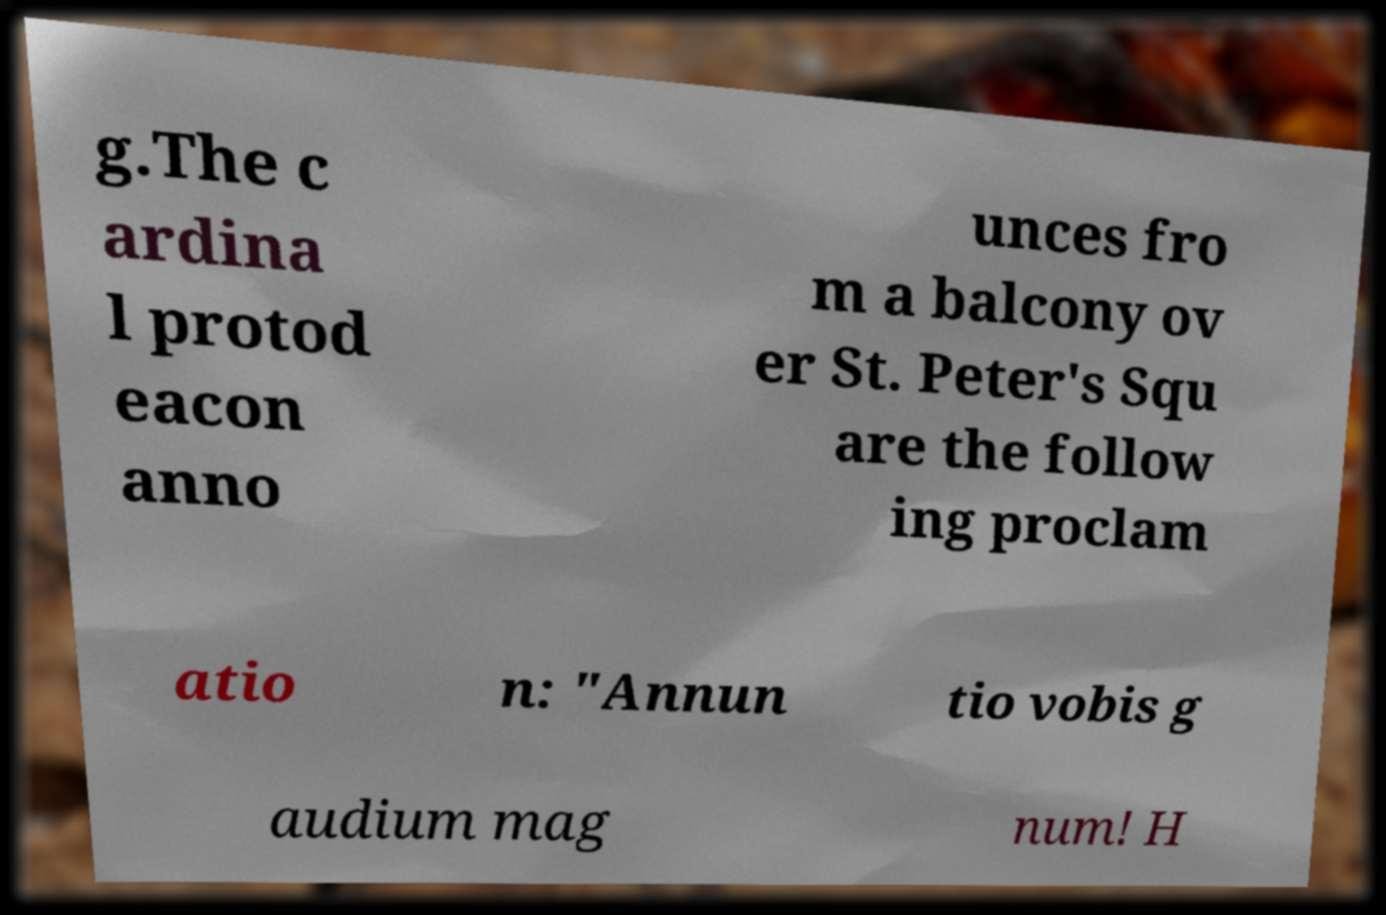There's text embedded in this image that I need extracted. Can you transcribe it verbatim? g.The c ardina l protod eacon anno unces fro m a balcony ov er St. Peter's Squ are the follow ing proclam atio n: "Annun tio vobis g audium mag num! H 